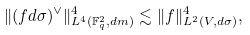Convert formula to latex. <formula><loc_0><loc_0><loc_500><loc_500>\| ( f d \sigma ) ^ { \vee } \| _ { L ^ { 4 } ( { \mathbb { F } _ { q } ^ { 2 } } , d m ) } ^ { 4 } \lesssim \| f \| _ { L ^ { 2 } ( V , d \sigma ) } ^ { 4 } ,</formula> 